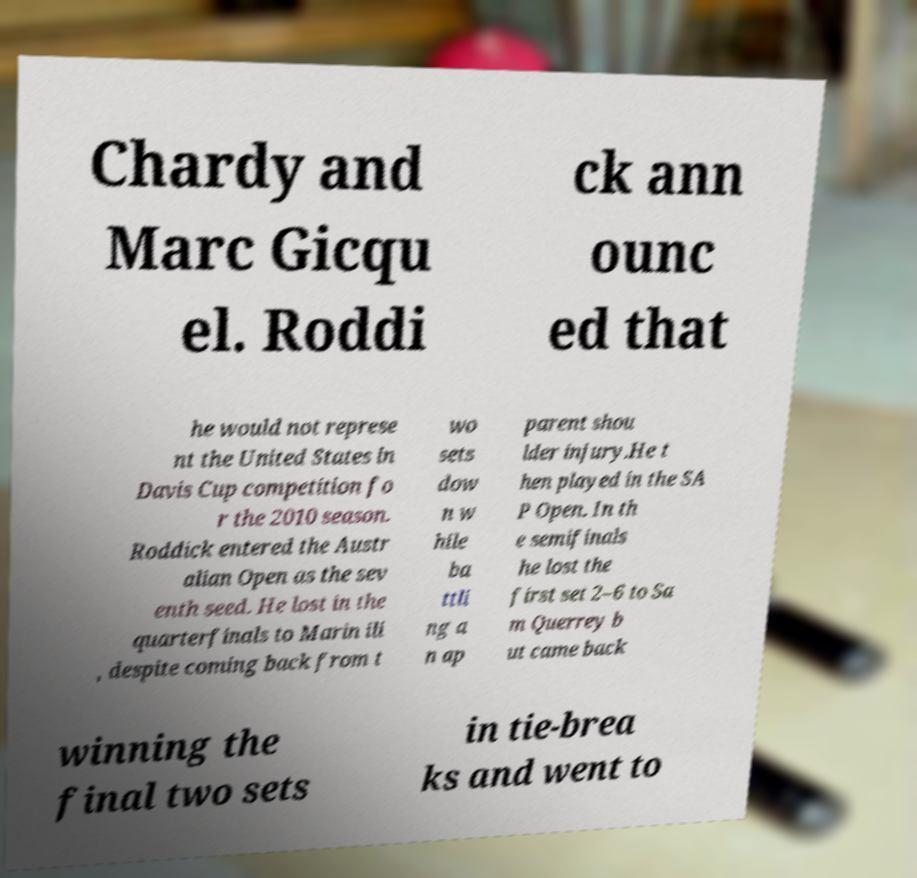Can you read and provide the text displayed in the image?This photo seems to have some interesting text. Can you extract and type it out for me? Chardy and Marc Gicqu el. Roddi ck ann ounc ed that he would not represe nt the United States in Davis Cup competition fo r the 2010 season. Roddick entered the Austr alian Open as the sev enth seed. He lost in the quarterfinals to Marin ili , despite coming back from t wo sets dow n w hile ba ttli ng a n ap parent shou lder injury.He t hen played in the SA P Open. In th e semifinals he lost the first set 2–6 to Sa m Querrey b ut came back winning the final two sets in tie-brea ks and went to 